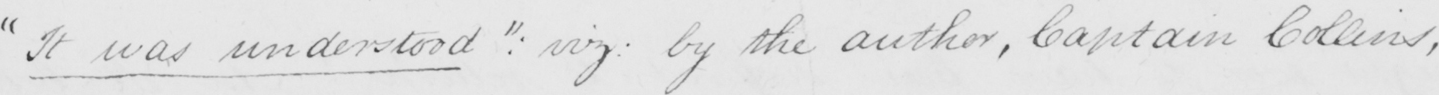Can you read and transcribe this handwriting? " It was understood "  :  viz :  by the author , Captain Collins , 